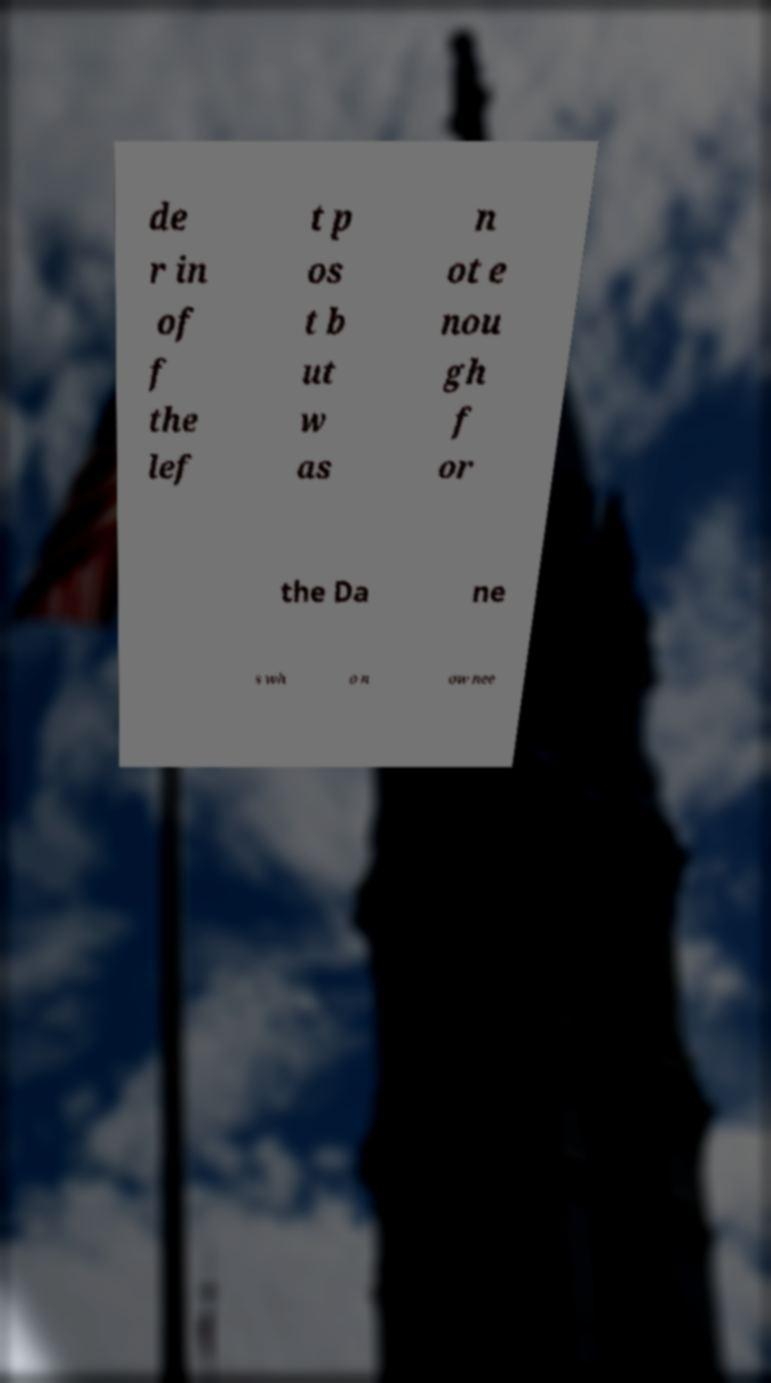Please identify and transcribe the text found in this image. de r in of f the lef t p os t b ut w as n ot e nou gh f or the Da ne s wh o n ow nee 